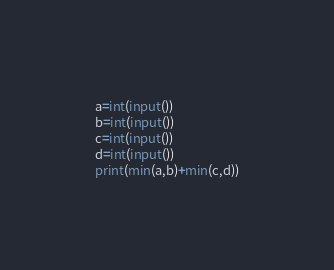<code> <loc_0><loc_0><loc_500><loc_500><_Python_>a=int(input())
b=int(input())
c=int(input())
d=int(input())
print(min(a,b)+min(c,d))</code> 